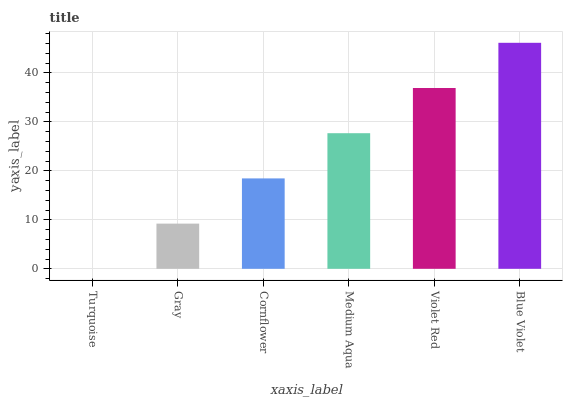Is Gray the minimum?
Answer yes or no. No. Is Gray the maximum?
Answer yes or no. No. Is Gray greater than Turquoise?
Answer yes or no. Yes. Is Turquoise less than Gray?
Answer yes or no. Yes. Is Turquoise greater than Gray?
Answer yes or no. No. Is Gray less than Turquoise?
Answer yes or no. No. Is Medium Aqua the high median?
Answer yes or no. Yes. Is Cornflower the low median?
Answer yes or no. Yes. Is Cornflower the high median?
Answer yes or no. No. Is Turquoise the low median?
Answer yes or no. No. 